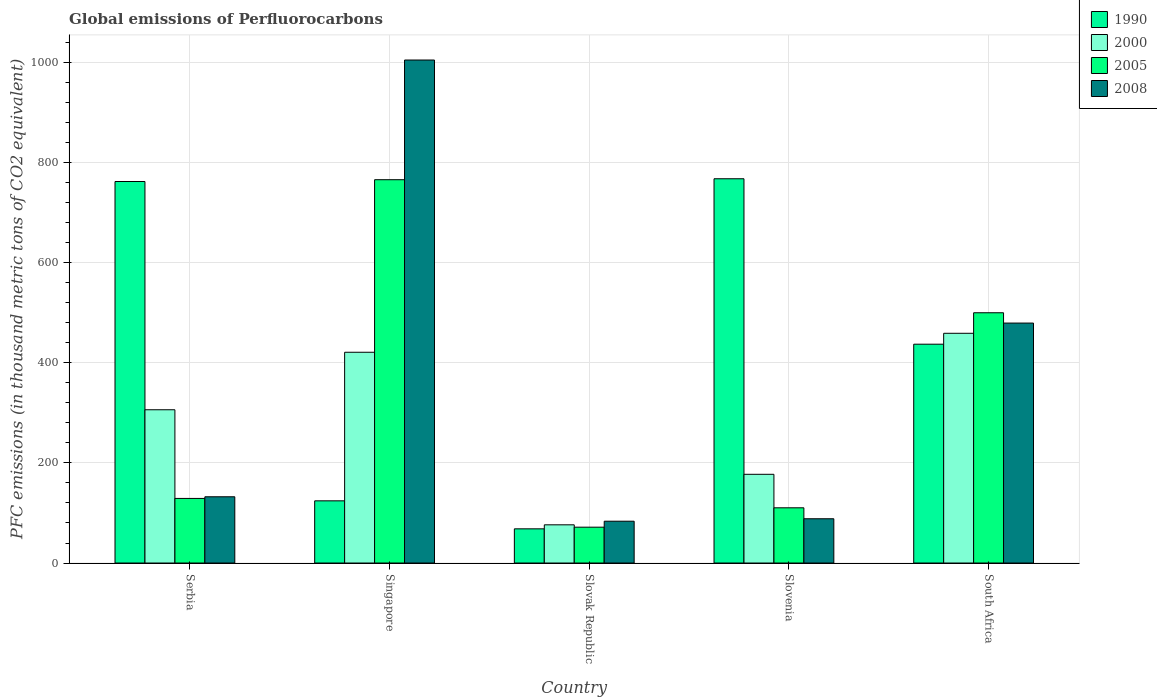How many different coloured bars are there?
Offer a terse response. 4. How many groups of bars are there?
Your answer should be very brief. 5. Are the number of bars per tick equal to the number of legend labels?
Offer a very short reply. Yes. How many bars are there on the 3rd tick from the left?
Your response must be concise. 4. How many bars are there on the 2nd tick from the right?
Offer a terse response. 4. What is the label of the 3rd group of bars from the left?
Give a very brief answer. Slovak Republic. What is the global emissions of Perfluorocarbons in 2005 in Singapore?
Provide a short and direct response. 765.5. Across all countries, what is the maximum global emissions of Perfluorocarbons in 1990?
Keep it short and to the point. 767.4. Across all countries, what is the minimum global emissions of Perfluorocarbons in 2000?
Your response must be concise. 76.3. In which country was the global emissions of Perfluorocarbons in 2005 maximum?
Your answer should be compact. Singapore. In which country was the global emissions of Perfluorocarbons in 2005 minimum?
Ensure brevity in your answer.  Slovak Republic. What is the total global emissions of Perfluorocarbons in 1990 in the graph?
Give a very brief answer. 2158.8. What is the difference between the global emissions of Perfluorocarbons in 2000 in Singapore and that in Slovak Republic?
Ensure brevity in your answer.  344.6. What is the difference between the global emissions of Perfluorocarbons in 1990 in Singapore and the global emissions of Perfluorocarbons in 2000 in Slovenia?
Offer a terse response. -53. What is the average global emissions of Perfluorocarbons in 1990 per country?
Give a very brief answer. 431.76. What is the difference between the global emissions of Perfluorocarbons of/in 1990 and global emissions of Perfluorocarbons of/in 2008 in Slovenia?
Offer a terse response. 679. In how many countries, is the global emissions of Perfluorocarbons in 2005 greater than 1000 thousand metric tons?
Your answer should be very brief. 0. What is the ratio of the global emissions of Perfluorocarbons in 2000 in Serbia to that in Singapore?
Your answer should be very brief. 0.73. Is the global emissions of Perfluorocarbons in 2005 in Slovenia less than that in South Africa?
Ensure brevity in your answer.  Yes. What is the difference between the highest and the second highest global emissions of Perfluorocarbons in 2008?
Keep it short and to the point. -872.2. What is the difference between the highest and the lowest global emissions of Perfluorocarbons in 1990?
Offer a very short reply. 699.1. How many bars are there?
Keep it short and to the point. 20. Are the values on the major ticks of Y-axis written in scientific E-notation?
Your answer should be compact. No. Does the graph contain grids?
Ensure brevity in your answer.  Yes. How many legend labels are there?
Provide a succinct answer. 4. What is the title of the graph?
Ensure brevity in your answer.  Global emissions of Perfluorocarbons. What is the label or title of the Y-axis?
Offer a very short reply. PFC emissions (in thousand metric tons of CO2 equivalent). What is the PFC emissions (in thousand metric tons of CO2 equivalent) of 1990 in Serbia?
Give a very brief answer. 761.9. What is the PFC emissions (in thousand metric tons of CO2 equivalent) in 2000 in Serbia?
Your response must be concise. 306.1. What is the PFC emissions (in thousand metric tons of CO2 equivalent) in 2005 in Serbia?
Provide a succinct answer. 129. What is the PFC emissions (in thousand metric tons of CO2 equivalent) of 2008 in Serbia?
Offer a very short reply. 132.3. What is the PFC emissions (in thousand metric tons of CO2 equivalent) of 1990 in Singapore?
Provide a short and direct response. 124.2. What is the PFC emissions (in thousand metric tons of CO2 equivalent) of 2000 in Singapore?
Provide a succinct answer. 420.9. What is the PFC emissions (in thousand metric tons of CO2 equivalent) of 2005 in Singapore?
Keep it short and to the point. 765.5. What is the PFC emissions (in thousand metric tons of CO2 equivalent) in 2008 in Singapore?
Make the answer very short. 1004.5. What is the PFC emissions (in thousand metric tons of CO2 equivalent) in 1990 in Slovak Republic?
Offer a very short reply. 68.3. What is the PFC emissions (in thousand metric tons of CO2 equivalent) of 2000 in Slovak Republic?
Your response must be concise. 76.3. What is the PFC emissions (in thousand metric tons of CO2 equivalent) in 2005 in Slovak Republic?
Your answer should be compact. 71.6. What is the PFC emissions (in thousand metric tons of CO2 equivalent) in 2008 in Slovak Republic?
Provide a short and direct response. 83.5. What is the PFC emissions (in thousand metric tons of CO2 equivalent) of 1990 in Slovenia?
Provide a short and direct response. 767.4. What is the PFC emissions (in thousand metric tons of CO2 equivalent) in 2000 in Slovenia?
Offer a terse response. 177.2. What is the PFC emissions (in thousand metric tons of CO2 equivalent) of 2005 in Slovenia?
Offer a terse response. 110.3. What is the PFC emissions (in thousand metric tons of CO2 equivalent) of 2008 in Slovenia?
Your answer should be compact. 88.4. What is the PFC emissions (in thousand metric tons of CO2 equivalent) of 1990 in South Africa?
Make the answer very short. 437. What is the PFC emissions (in thousand metric tons of CO2 equivalent) in 2000 in South Africa?
Your answer should be very brief. 458.8. What is the PFC emissions (in thousand metric tons of CO2 equivalent) of 2005 in South Africa?
Keep it short and to the point. 499.8. What is the PFC emissions (in thousand metric tons of CO2 equivalent) in 2008 in South Africa?
Your response must be concise. 479.2. Across all countries, what is the maximum PFC emissions (in thousand metric tons of CO2 equivalent) of 1990?
Your answer should be very brief. 767.4. Across all countries, what is the maximum PFC emissions (in thousand metric tons of CO2 equivalent) in 2000?
Your answer should be compact. 458.8. Across all countries, what is the maximum PFC emissions (in thousand metric tons of CO2 equivalent) of 2005?
Offer a very short reply. 765.5. Across all countries, what is the maximum PFC emissions (in thousand metric tons of CO2 equivalent) of 2008?
Give a very brief answer. 1004.5. Across all countries, what is the minimum PFC emissions (in thousand metric tons of CO2 equivalent) of 1990?
Provide a short and direct response. 68.3. Across all countries, what is the minimum PFC emissions (in thousand metric tons of CO2 equivalent) in 2000?
Provide a short and direct response. 76.3. Across all countries, what is the minimum PFC emissions (in thousand metric tons of CO2 equivalent) of 2005?
Provide a short and direct response. 71.6. Across all countries, what is the minimum PFC emissions (in thousand metric tons of CO2 equivalent) in 2008?
Provide a succinct answer. 83.5. What is the total PFC emissions (in thousand metric tons of CO2 equivalent) in 1990 in the graph?
Give a very brief answer. 2158.8. What is the total PFC emissions (in thousand metric tons of CO2 equivalent) of 2000 in the graph?
Give a very brief answer. 1439.3. What is the total PFC emissions (in thousand metric tons of CO2 equivalent) in 2005 in the graph?
Provide a short and direct response. 1576.2. What is the total PFC emissions (in thousand metric tons of CO2 equivalent) in 2008 in the graph?
Ensure brevity in your answer.  1787.9. What is the difference between the PFC emissions (in thousand metric tons of CO2 equivalent) of 1990 in Serbia and that in Singapore?
Your response must be concise. 637.7. What is the difference between the PFC emissions (in thousand metric tons of CO2 equivalent) in 2000 in Serbia and that in Singapore?
Provide a succinct answer. -114.8. What is the difference between the PFC emissions (in thousand metric tons of CO2 equivalent) in 2005 in Serbia and that in Singapore?
Keep it short and to the point. -636.5. What is the difference between the PFC emissions (in thousand metric tons of CO2 equivalent) in 2008 in Serbia and that in Singapore?
Ensure brevity in your answer.  -872.2. What is the difference between the PFC emissions (in thousand metric tons of CO2 equivalent) in 1990 in Serbia and that in Slovak Republic?
Give a very brief answer. 693.6. What is the difference between the PFC emissions (in thousand metric tons of CO2 equivalent) of 2000 in Serbia and that in Slovak Republic?
Ensure brevity in your answer.  229.8. What is the difference between the PFC emissions (in thousand metric tons of CO2 equivalent) in 2005 in Serbia and that in Slovak Republic?
Your answer should be compact. 57.4. What is the difference between the PFC emissions (in thousand metric tons of CO2 equivalent) in 2008 in Serbia and that in Slovak Republic?
Provide a succinct answer. 48.8. What is the difference between the PFC emissions (in thousand metric tons of CO2 equivalent) in 2000 in Serbia and that in Slovenia?
Keep it short and to the point. 128.9. What is the difference between the PFC emissions (in thousand metric tons of CO2 equivalent) in 2008 in Serbia and that in Slovenia?
Provide a short and direct response. 43.9. What is the difference between the PFC emissions (in thousand metric tons of CO2 equivalent) in 1990 in Serbia and that in South Africa?
Offer a terse response. 324.9. What is the difference between the PFC emissions (in thousand metric tons of CO2 equivalent) in 2000 in Serbia and that in South Africa?
Give a very brief answer. -152.7. What is the difference between the PFC emissions (in thousand metric tons of CO2 equivalent) in 2005 in Serbia and that in South Africa?
Provide a succinct answer. -370.8. What is the difference between the PFC emissions (in thousand metric tons of CO2 equivalent) in 2008 in Serbia and that in South Africa?
Your answer should be compact. -346.9. What is the difference between the PFC emissions (in thousand metric tons of CO2 equivalent) in 1990 in Singapore and that in Slovak Republic?
Make the answer very short. 55.9. What is the difference between the PFC emissions (in thousand metric tons of CO2 equivalent) of 2000 in Singapore and that in Slovak Republic?
Offer a very short reply. 344.6. What is the difference between the PFC emissions (in thousand metric tons of CO2 equivalent) in 2005 in Singapore and that in Slovak Republic?
Your answer should be compact. 693.9. What is the difference between the PFC emissions (in thousand metric tons of CO2 equivalent) of 2008 in Singapore and that in Slovak Republic?
Your answer should be compact. 921. What is the difference between the PFC emissions (in thousand metric tons of CO2 equivalent) in 1990 in Singapore and that in Slovenia?
Ensure brevity in your answer.  -643.2. What is the difference between the PFC emissions (in thousand metric tons of CO2 equivalent) of 2000 in Singapore and that in Slovenia?
Offer a very short reply. 243.7. What is the difference between the PFC emissions (in thousand metric tons of CO2 equivalent) in 2005 in Singapore and that in Slovenia?
Provide a succinct answer. 655.2. What is the difference between the PFC emissions (in thousand metric tons of CO2 equivalent) in 2008 in Singapore and that in Slovenia?
Give a very brief answer. 916.1. What is the difference between the PFC emissions (in thousand metric tons of CO2 equivalent) of 1990 in Singapore and that in South Africa?
Offer a terse response. -312.8. What is the difference between the PFC emissions (in thousand metric tons of CO2 equivalent) of 2000 in Singapore and that in South Africa?
Your answer should be compact. -37.9. What is the difference between the PFC emissions (in thousand metric tons of CO2 equivalent) in 2005 in Singapore and that in South Africa?
Your answer should be compact. 265.7. What is the difference between the PFC emissions (in thousand metric tons of CO2 equivalent) in 2008 in Singapore and that in South Africa?
Give a very brief answer. 525.3. What is the difference between the PFC emissions (in thousand metric tons of CO2 equivalent) of 1990 in Slovak Republic and that in Slovenia?
Give a very brief answer. -699.1. What is the difference between the PFC emissions (in thousand metric tons of CO2 equivalent) in 2000 in Slovak Republic and that in Slovenia?
Provide a succinct answer. -100.9. What is the difference between the PFC emissions (in thousand metric tons of CO2 equivalent) of 2005 in Slovak Republic and that in Slovenia?
Keep it short and to the point. -38.7. What is the difference between the PFC emissions (in thousand metric tons of CO2 equivalent) of 1990 in Slovak Republic and that in South Africa?
Make the answer very short. -368.7. What is the difference between the PFC emissions (in thousand metric tons of CO2 equivalent) of 2000 in Slovak Republic and that in South Africa?
Provide a short and direct response. -382.5. What is the difference between the PFC emissions (in thousand metric tons of CO2 equivalent) of 2005 in Slovak Republic and that in South Africa?
Your answer should be very brief. -428.2. What is the difference between the PFC emissions (in thousand metric tons of CO2 equivalent) of 2008 in Slovak Republic and that in South Africa?
Your answer should be compact. -395.7. What is the difference between the PFC emissions (in thousand metric tons of CO2 equivalent) in 1990 in Slovenia and that in South Africa?
Give a very brief answer. 330.4. What is the difference between the PFC emissions (in thousand metric tons of CO2 equivalent) in 2000 in Slovenia and that in South Africa?
Provide a succinct answer. -281.6. What is the difference between the PFC emissions (in thousand metric tons of CO2 equivalent) of 2005 in Slovenia and that in South Africa?
Offer a very short reply. -389.5. What is the difference between the PFC emissions (in thousand metric tons of CO2 equivalent) of 2008 in Slovenia and that in South Africa?
Offer a very short reply. -390.8. What is the difference between the PFC emissions (in thousand metric tons of CO2 equivalent) of 1990 in Serbia and the PFC emissions (in thousand metric tons of CO2 equivalent) of 2000 in Singapore?
Offer a terse response. 341. What is the difference between the PFC emissions (in thousand metric tons of CO2 equivalent) of 1990 in Serbia and the PFC emissions (in thousand metric tons of CO2 equivalent) of 2005 in Singapore?
Offer a terse response. -3.6. What is the difference between the PFC emissions (in thousand metric tons of CO2 equivalent) of 1990 in Serbia and the PFC emissions (in thousand metric tons of CO2 equivalent) of 2008 in Singapore?
Offer a terse response. -242.6. What is the difference between the PFC emissions (in thousand metric tons of CO2 equivalent) of 2000 in Serbia and the PFC emissions (in thousand metric tons of CO2 equivalent) of 2005 in Singapore?
Ensure brevity in your answer.  -459.4. What is the difference between the PFC emissions (in thousand metric tons of CO2 equivalent) in 2000 in Serbia and the PFC emissions (in thousand metric tons of CO2 equivalent) in 2008 in Singapore?
Make the answer very short. -698.4. What is the difference between the PFC emissions (in thousand metric tons of CO2 equivalent) of 2005 in Serbia and the PFC emissions (in thousand metric tons of CO2 equivalent) of 2008 in Singapore?
Offer a terse response. -875.5. What is the difference between the PFC emissions (in thousand metric tons of CO2 equivalent) of 1990 in Serbia and the PFC emissions (in thousand metric tons of CO2 equivalent) of 2000 in Slovak Republic?
Give a very brief answer. 685.6. What is the difference between the PFC emissions (in thousand metric tons of CO2 equivalent) of 1990 in Serbia and the PFC emissions (in thousand metric tons of CO2 equivalent) of 2005 in Slovak Republic?
Ensure brevity in your answer.  690.3. What is the difference between the PFC emissions (in thousand metric tons of CO2 equivalent) of 1990 in Serbia and the PFC emissions (in thousand metric tons of CO2 equivalent) of 2008 in Slovak Republic?
Ensure brevity in your answer.  678.4. What is the difference between the PFC emissions (in thousand metric tons of CO2 equivalent) of 2000 in Serbia and the PFC emissions (in thousand metric tons of CO2 equivalent) of 2005 in Slovak Republic?
Provide a short and direct response. 234.5. What is the difference between the PFC emissions (in thousand metric tons of CO2 equivalent) of 2000 in Serbia and the PFC emissions (in thousand metric tons of CO2 equivalent) of 2008 in Slovak Republic?
Offer a very short reply. 222.6. What is the difference between the PFC emissions (in thousand metric tons of CO2 equivalent) in 2005 in Serbia and the PFC emissions (in thousand metric tons of CO2 equivalent) in 2008 in Slovak Republic?
Ensure brevity in your answer.  45.5. What is the difference between the PFC emissions (in thousand metric tons of CO2 equivalent) in 1990 in Serbia and the PFC emissions (in thousand metric tons of CO2 equivalent) in 2000 in Slovenia?
Offer a very short reply. 584.7. What is the difference between the PFC emissions (in thousand metric tons of CO2 equivalent) in 1990 in Serbia and the PFC emissions (in thousand metric tons of CO2 equivalent) in 2005 in Slovenia?
Your response must be concise. 651.6. What is the difference between the PFC emissions (in thousand metric tons of CO2 equivalent) of 1990 in Serbia and the PFC emissions (in thousand metric tons of CO2 equivalent) of 2008 in Slovenia?
Give a very brief answer. 673.5. What is the difference between the PFC emissions (in thousand metric tons of CO2 equivalent) in 2000 in Serbia and the PFC emissions (in thousand metric tons of CO2 equivalent) in 2005 in Slovenia?
Provide a succinct answer. 195.8. What is the difference between the PFC emissions (in thousand metric tons of CO2 equivalent) of 2000 in Serbia and the PFC emissions (in thousand metric tons of CO2 equivalent) of 2008 in Slovenia?
Your response must be concise. 217.7. What is the difference between the PFC emissions (in thousand metric tons of CO2 equivalent) in 2005 in Serbia and the PFC emissions (in thousand metric tons of CO2 equivalent) in 2008 in Slovenia?
Provide a succinct answer. 40.6. What is the difference between the PFC emissions (in thousand metric tons of CO2 equivalent) in 1990 in Serbia and the PFC emissions (in thousand metric tons of CO2 equivalent) in 2000 in South Africa?
Offer a terse response. 303.1. What is the difference between the PFC emissions (in thousand metric tons of CO2 equivalent) of 1990 in Serbia and the PFC emissions (in thousand metric tons of CO2 equivalent) of 2005 in South Africa?
Your answer should be very brief. 262.1. What is the difference between the PFC emissions (in thousand metric tons of CO2 equivalent) in 1990 in Serbia and the PFC emissions (in thousand metric tons of CO2 equivalent) in 2008 in South Africa?
Keep it short and to the point. 282.7. What is the difference between the PFC emissions (in thousand metric tons of CO2 equivalent) of 2000 in Serbia and the PFC emissions (in thousand metric tons of CO2 equivalent) of 2005 in South Africa?
Keep it short and to the point. -193.7. What is the difference between the PFC emissions (in thousand metric tons of CO2 equivalent) in 2000 in Serbia and the PFC emissions (in thousand metric tons of CO2 equivalent) in 2008 in South Africa?
Offer a very short reply. -173.1. What is the difference between the PFC emissions (in thousand metric tons of CO2 equivalent) in 2005 in Serbia and the PFC emissions (in thousand metric tons of CO2 equivalent) in 2008 in South Africa?
Offer a terse response. -350.2. What is the difference between the PFC emissions (in thousand metric tons of CO2 equivalent) of 1990 in Singapore and the PFC emissions (in thousand metric tons of CO2 equivalent) of 2000 in Slovak Republic?
Your answer should be compact. 47.9. What is the difference between the PFC emissions (in thousand metric tons of CO2 equivalent) of 1990 in Singapore and the PFC emissions (in thousand metric tons of CO2 equivalent) of 2005 in Slovak Republic?
Your response must be concise. 52.6. What is the difference between the PFC emissions (in thousand metric tons of CO2 equivalent) in 1990 in Singapore and the PFC emissions (in thousand metric tons of CO2 equivalent) in 2008 in Slovak Republic?
Ensure brevity in your answer.  40.7. What is the difference between the PFC emissions (in thousand metric tons of CO2 equivalent) in 2000 in Singapore and the PFC emissions (in thousand metric tons of CO2 equivalent) in 2005 in Slovak Republic?
Offer a terse response. 349.3. What is the difference between the PFC emissions (in thousand metric tons of CO2 equivalent) of 2000 in Singapore and the PFC emissions (in thousand metric tons of CO2 equivalent) of 2008 in Slovak Republic?
Your response must be concise. 337.4. What is the difference between the PFC emissions (in thousand metric tons of CO2 equivalent) of 2005 in Singapore and the PFC emissions (in thousand metric tons of CO2 equivalent) of 2008 in Slovak Republic?
Your answer should be very brief. 682. What is the difference between the PFC emissions (in thousand metric tons of CO2 equivalent) in 1990 in Singapore and the PFC emissions (in thousand metric tons of CO2 equivalent) in 2000 in Slovenia?
Your response must be concise. -53. What is the difference between the PFC emissions (in thousand metric tons of CO2 equivalent) of 1990 in Singapore and the PFC emissions (in thousand metric tons of CO2 equivalent) of 2008 in Slovenia?
Your answer should be very brief. 35.8. What is the difference between the PFC emissions (in thousand metric tons of CO2 equivalent) of 2000 in Singapore and the PFC emissions (in thousand metric tons of CO2 equivalent) of 2005 in Slovenia?
Your response must be concise. 310.6. What is the difference between the PFC emissions (in thousand metric tons of CO2 equivalent) of 2000 in Singapore and the PFC emissions (in thousand metric tons of CO2 equivalent) of 2008 in Slovenia?
Give a very brief answer. 332.5. What is the difference between the PFC emissions (in thousand metric tons of CO2 equivalent) in 2005 in Singapore and the PFC emissions (in thousand metric tons of CO2 equivalent) in 2008 in Slovenia?
Make the answer very short. 677.1. What is the difference between the PFC emissions (in thousand metric tons of CO2 equivalent) in 1990 in Singapore and the PFC emissions (in thousand metric tons of CO2 equivalent) in 2000 in South Africa?
Provide a short and direct response. -334.6. What is the difference between the PFC emissions (in thousand metric tons of CO2 equivalent) in 1990 in Singapore and the PFC emissions (in thousand metric tons of CO2 equivalent) in 2005 in South Africa?
Give a very brief answer. -375.6. What is the difference between the PFC emissions (in thousand metric tons of CO2 equivalent) of 1990 in Singapore and the PFC emissions (in thousand metric tons of CO2 equivalent) of 2008 in South Africa?
Give a very brief answer. -355. What is the difference between the PFC emissions (in thousand metric tons of CO2 equivalent) in 2000 in Singapore and the PFC emissions (in thousand metric tons of CO2 equivalent) in 2005 in South Africa?
Provide a short and direct response. -78.9. What is the difference between the PFC emissions (in thousand metric tons of CO2 equivalent) in 2000 in Singapore and the PFC emissions (in thousand metric tons of CO2 equivalent) in 2008 in South Africa?
Keep it short and to the point. -58.3. What is the difference between the PFC emissions (in thousand metric tons of CO2 equivalent) in 2005 in Singapore and the PFC emissions (in thousand metric tons of CO2 equivalent) in 2008 in South Africa?
Offer a terse response. 286.3. What is the difference between the PFC emissions (in thousand metric tons of CO2 equivalent) of 1990 in Slovak Republic and the PFC emissions (in thousand metric tons of CO2 equivalent) of 2000 in Slovenia?
Your answer should be compact. -108.9. What is the difference between the PFC emissions (in thousand metric tons of CO2 equivalent) of 1990 in Slovak Republic and the PFC emissions (in thousand metric tons of CO2 equivalent) of 2005 in Slovenia?
Offer a terse response. -42. What is the difference between the PFC emissions (in thousand metric tons of CO2 equivalent) of 1990 in Slovak Republic and the PFC emissions (in thousand metric tons of CO2 equivalent) of 2008 in Slovenia?
Your answer should be very brief. -20.1. What is the difference between the PFC emissions (in thousand metric tons of CO2 equivalent) of 2000 in Slovak Republic and the PFC emissions (in thousand metric tons of CO2 equivalent) of 2005 in Slovenia?
Give a very brief answer. -34. What is the difference between the PFC emissions (in thousand metric tons of CO2 equivalent) in 2000 in Slovak Republic and the PFC emissions (in thousand metric tons of CO2 equivalent) in 2008 in Slovenia?
Your answer should be very brief. -12.1. What is the difference between the PFC emissions (in thousand metric tons of CO2 equivalent) in 2005 in Slovak Republic and the PFC emissions (in thousand metric tons of CO2 equivalent) in 2008 in Slovenia?
Provide a short and direct response. -16.8. What is the difference between the PFC emissions (in thousand metric tons of CO2 equivalent) of 1990 in Slovak Republic and the PFC emissions (in thousand metric tons of CO2 equivalent) of 2000 in South Africa?
Make the answer very short. -390.5. What is the difference between the PFC emissions (in thousand metric tons of CO2 equivalent) of 1990 in Slovak Republic and the PFC emissions (in thousand metric tons of CO2 equivalent) of 2005 in South Africa?
Your response must be concise. -431.5. What is the difference between the PFC emissions (in thousand metric tons of CO2 equivalent) of 1990 in Slovak Republic and the PFC emissions (in thousand metric tons of CO2 equivalent) of 2008 in South Africa?
Your answer should be compact. -410.9. What is the difference between the PFC emissions (in thousand metric tons of CO2 equivalent) in 2000 in Slovak Republic and the PFC emissions (in thousand metric tons of CO2 equivalent) in 2005 in South Africa?
Give a very brief answer. -423.5. What is the difference between the PFC emissions (in thousand metric tons of CO2 equivalent) in 2000 in Slovak Republic and the PFC emissions (in thousand metric tons of CO2 equivalent) in 2008 in South Africa?
Provide a succinct answer. -402.9. What is the difference between the PFC emissions (in thousand metric tons of CO2 equivalent) of 2005 in Slovak Republic and the PFC emissions (in thousand metric tons of CO2 equivalent) of 2008 in South Africa?
Your answer should be very brief. -407.6. What is the difference between the PFC emissions (in thousand metric tons of CO2 equivalent) of 1990 in Slovenia and the PFC emissions (in thousand metric tons of CO2 equivalent) of 2000 in South Africa?
Make the answer very short. 308.6. What is the difference between the PFC emissions (in thousand metric tons of CO2 equivalent) of 1990 in Slovenia and the PFC emissions (in thousand metric tons of CO2 equivalent) of 2005 in South Africa?
Your response must be concise. 267.6. What is the difference between the PFC emissions (in thousand metric tons of CO2 equivalent) in 1990 in Slovenia and the PFC emissions (in thousand metric tons of CO2 equivalent) in 2008 in South Africa?
Keep it short and to the point. 288.2. What is the difference between the PFC emissions (in thousand metric tons of CO2 equivalent) of 2000 in Slovenia and the PFC emissions (in thousand metric tons of CO2 equivalent) of 2005 in South Africa?
Your answer should be compact. -322.6. What is the difference between the PFC emissions (in thousand metric tons of CO2 equivalent) of 2000 in Slovenia and the PFC emissions (in thousand metric tons of CO2 equivalent) of 2008 in South Africa?
Your response must be concise. -302. What is the difference between the PFC emissions (in thousand metric tons of CO2 equivalent) in 2005 in Slovenia and the PFC emissions (in thousand metric tons of CO2 equivalent) in 2008 in South Africa?
Provide a succinct answer. -368.9. What is the average PFC emissions (in thousand metric tons of CO2 equivalent) of 1990 per country?
Provide a succinct answer. 431.76. What is the average PFC emissions (in thousand metric tons of CO2 equivalent) of 2000 per country?
Your answer should be compact. 287.86. What is the average PFC emissions (in thousand metric tons of CO2 equivalent) of 2005 per country?
Your response must be concise. 315.24. What is the average PFC emissions (in thousand metric tons of CO2 equivalent) of 2008 per country?
Make the answer very short. 357.58. What is the difference between the PFC emissions (in thousand metric tons of CO2 equivalent) of 1990 and PFC emissions (in thousand metric tons of CO2 equivalent) of 2000 in Serbia?
Give a very brief answer. 455.8. What is the difference between the PFC emissions (in thousand metric tons of CO2 equivalent) of 1990 and PFC emissions (in thousand metric tons of CO2 equivalent) of 2005 in Serbia?
Your answer should be very brief. 632.9. What is the difference between the PFC emissions (in thousand metric tons of CO2 equivalent) of 1990 and PFC emissions (in thousand metric tons of CO2 equivalent) of 2008 in Serbia?
Provide a short and direct response. 629.6. What is the difference between the PFC emissions (in thousand metric tons of CO2 equivalent) in 2000 and PFC emissions (in thousand metric tons of CO2 equivalent) in 2005 in Serbia?
Your response must be concise. 177.1. What is the difference between the PFC emissions (in thousand metric tons of CO2 equivalent) in 2000 and PFC emissions (in thousand metric tons of CO2 equivalent) in 2008 in Serbia?
Your answer should be compact. 173.8. What is the difference between the PFC emissions (in thousand metric tons of CO2 equivalent) of 2005 and PFC emissions (in thousand metric tons of CO2 equivalent) of 2008 in Serbia?
Make the answer very short. -3.3. What is the difference between the PFC emissions (in thousand metric tons of CO2 equivalent) in 1990 and PFC emissions (in thousand metric tons of CO2 equivalent) in 2000 in Singapore?
Your response must be concise. -296.7. What is the difference between the PFC emissions (in thousand metric tons of CO2 equivalent) in 1990 and PFC emissions (in thousand metric tons of CO2 equivalent) in 2005 in Singapore?
Offer a very short reply. -641.3. What is the difference between the PFC emissions (in thousand metric tons of CO2 equivalent) of 1990 and PFC emissions (in thousand metric tons of CO2 equivalent) of 2008 in Singapore?
Offer a very short reply. -880.3. What is the difference between the PFC emissions (in thousand metric tons of CO2 equivalent) of 2000 and PFC emissions (in thousand metric tons of CO2 equivalent) of 2005 in Singapore?
Make the answer very short. -344.6. What is the difference between the PFC emissions (in thousand metric tons of CO2 equivalent) in 2000 and PFC emissions (in thousand metric tons of CO2 equivalent) in 2008 in Singapore?
Give a very brief answer. -583.6. What is the difference between the PFC emissions (in thousand metric tons of CO2 equivalent) of 2005 and PFC emissions (in thousand metric tons of CO2 equivalent) of 2008 in Singapore?
Your answer should be compact. -239. What is the difference between the PFC emissions (in thousand metric tons of CO2 equivalent) of 1990 and PFC emissions (in thousand metric tons of CO2 equivalent) of 2008 in Slovak Republic?
Ensure brevity in your answer.  -15.2. What is the difference between the PFC emissions (in thousand metric tons of CO2 equivalent) in 2000 and PFC emissions (in thousand metric tons of CO2 equivalent) in 2008 in Slovak Republic?
Your answer should be compact. -7.2. What is the difference between the PFC emissions (in thousand metric tons of CO2 equivalent) in 1990 and PFC emissions (in thousand metric tons of CO2 equivalent) in 2000 in Slovenia?
Your answer should be compact. 590.2. What is the difference between the PFC emissions (in thousand metric tons of CO2 equivalent) in 1990 and PFC emissions (in thousand metric tons of CO2 equivalent) in 2005 in Slovenia?
Keep it short and to the point. 657.1. What is the difference between the PFC emissions (in thousand metric tons of CO2 equivalent) in 1990 and PFC emissions (in thousand metric tons of CO2 equivalent) in 2008 in Slovenia?
Make the answer very short. 679. What is the difference between the PFC emissions (in thousand metric tons of CO2 equivalent) in 2000 and PFC emissions (in thousand metric tons of CO2 equivalent) in 2005 in Slovenia?
Provide a succinct answer. 66.9. What is the difference between the PFC emissions (in thousand metric tons of CO2 equivalent) in 2000 and PFC emissions (in thousand metric tons of CO2 equivalent) in 2008 in Slovenia?
Offer a terse response. 88.8. What is the difference between the PFC emissions (in thousand metric tons of CO2 equivalent) in 2005 and PFC emissions (in thousand metric tons of CO2 equivalent) in 2008 in Slovenia?
Make the answer very short. 21.9. What is the difference between the PFC emissions (in thousand metric tons of CO2 equivalent) in 1990 and PFC emissions (in thousand metric tons of CO2 equivalent) in 2000 in South Africa?
Your answer should be compact. -21.8. What is the difference between the PFC emissions (in thousand metric tons of CO2 equivalent) of 1990 and PFC emissions (in thousand metric tons of CO2 equivalent) of 2005 in South Africa?
Give a very brief answer. -62.8. What is the difference between the PFC emissions (in thousand metric tons of CO2 equivalent) of 1990 and PFC emissions (in thousand metric tons of CO2 equivalent) of 2008 in South Africa?
Provide a succinct answer. -42.2. What is the difference between the PFC emissions (in thousand metric tons of CO2 equivalent) of 2000 and PFC emissions (in thousand metric tons of CO2 equivalent) of 2005 in South Africa?
Offer a very short reply. -41. What is the difference between the PFC emissions (in thousand metric tons of CO2 equivalent) of 2000 and PFC emissions (in thousand metric tons of CO2 equivalent) of 2008 in South Africa?
Provide a short and direct response. -20.4. What is the difference between the PFC emissions (in thousand metric tons of CO2 equivalent) of 2005 and PFC emissions (in thousand metric tons of CO2 equivalent) of 2008 in South Africa?
Offer a very short reply. 20.6. What is the ratio of the PFC emissions (in thousand metric tons of CO2 equivalent) of 1990 in Serbia to that in Singapore?
Offer a terse response. 6.13. What is the ratio of the PFC emissions (in thousand metric tons of CO2 equivalent) in 2000 in Serbia to that in Singapore?
Your answer should be compact. 0.73. What is the ratio of the PFC emissions (in thousand metric tons of CO2 equivalent) of 2005 in Serbia to that in Singapore?
Provide a succinct answer. 0.17. What is the ratio of the PFC emissions (in thousand metric tons of CO2 equivalent) in 2008 in Serbia to that in Singapore?
Offer a terse response. 0.13. What is the ratio of the PFC emissions (in thousand metric tons of CO2 equivalent) in 1990 in Serbia to that in Slovak Republic?
Provide a short and direct response. 11.16. What is the ratio of the PFC emissions (in thousand metric tons of CO2 equivalent) of 2000 in Serbia to that in Slovak Republic?
Your answer should be very brief. 4.01. What is the ratio of the PFC emissions (in thousand metric tons of CO2 equivalent) in 2005 in Serbia to that in Slovak Republic?
Keep it short and to the point. 1.8. What is the ratio of the PFC emissions (in thousand metric tons of CO2 equivalent) of 2008 in Serbia to that in Slovak Republic?
Your answer should be very brief. 1.58. What is the ratio of the PFC emissions (in thousand metric tons of CO2 equivalent) in 1990 in Serbia to that in Slovenia?
Your response must be concise. 0.99. What is the ratio of the PFC emissions (in thousand metric tons of CO2 equivalent) of 2000 in Serbia to that in Slovenia?
Give a very brief answer. 1.73. What is the ratio of the PFC emissions (in thousand metric tons of CO2 equivalent) in 2005 in Serbia to that in Slovenia?
Offer a very short reply. 1.17. What is the ratio of the PFC emissions (in thousand metric tons of CO2 equivalent) in 2008 in Serbia to that in Slovenia?
Your response must be concise. 1.5. What is the ratio of the PFC emissions (in thousand metric tons of CO2 equivalent) of 1990 in Serbia to that in South Africa?
Your answer should be compact. 1.74. What is the ratio of the PFC emissions (in thousand metric tons of CO2 equivalent) in 2000 in Serbia to that in South Africa?
Your response must be concise. 0.67. What is the ratio of the PFC emissions (in thousand metric tons of CO2 equivalent) of 2005 in Serbia to that in South Africa?
Provide a succinct answer. 0.26. What is the ratio of the PFC emissions (in thousand metric tons of CO2 equivalent) of 2008 in Serbia to that in South Africa?
Your answer should be very brief. 0.28. What is the ratio of the PFC emissions (in thousand metric tons of CO2 equivalent) of 1990 in Singapore to that in Slovak Republic?
Keep it short and to the point. 1.82. What is the ratio of the PFC emissions (in thousand metric tons of CO2 equivalent) in 2000 in Singapore to that in Slovak Republic?
Make the answer very short. 5.52. What is the ratio of the PFC emissions (in thousand metric tons of CO2 equivalent) in 2005 in Singapore to that in Slovak Republic?
Your answer should be compact. 10.69. What is the ratio of the PFC emissions (in thousand metric tons of CO2 equivalent) in 2008 in Singapore to that in Slovak Republic?
Your response must be concise. 12.03. What is the ratio of the PFC emissions (in thousand metric tons of CO2 equivalent) of 1990 in Singapore to that in Slovenia?
Provide a short and direct response. 0.16. What is the ratio of the PFC emissions (in thousand metric tons of CO2 equivalent) in 2000 in Singapore to that in Slovenia?
Offer a terse response. 2.38. What is the ratio of the PFC emissions (in thousand metric tons of CO2 equivalent) of 2005 in Singapore to that in Slovenia?
Give a very brief answer. 6.94. What is the ratio of the PFC emissions (in thousand metric tons of CO2 equivalent) in 2008 in Singapore to that in Slovenia?
Keep it short and to the point. 11.36. What is the ratio of the PFC emissions (in thousand metric tons of CO2 equivalent) of 1990 in Singapore to that in South Africa?
Your answer should be very brief. 0.28. What is the ratio of the PFC emissions (in thousand metric tons of CO2 equivalent) in 2000 in Singapore to that in South Africa?
Your answer should be compact. 0.92. What is the ratio of the PFC emissions (in thousand metric tons of CO2 equivalent) of 2005 in Singapore to that in South Africa?
Keep it short and to the point. 1.53. What is the ratio of the PFC emissions (in thousand metric tons of CO2 equivalent) in 2008 in Singapore to that in South Africa?
Make the answer very short. 2.1. What is the ratio of the PFC emissions (in thousand metric tons of CO2 equivalent) of 1990 in Slovak Republic to that in Slovenia?
Keep it short and to the point. 0.09. What is the ratio of the PFC emissions (in thousand metric tons of CO2 equivalent) in 2000 in Slovak Republic to that in Slovenia?
Offer a terse response. 0.43. What is the ratio of the PFC emissions (in thousand metric tons of CO2 equivalent) of 2005 in Slovak Republic to that in Slovenia?
Offer a terse response. 0.65. What is the ratio of the PFC emissions (in thousand metric tons of CO2 equivalent) in 2008 in Slovak Republic to that in Slovenia?
Offer a very short reply. 0.94. What is the ratio of the PFC emissions (in thousand metric tons of CO2 equivalent) in 1990 in Slovak Republic to that in South Africa?
Offer a terse response. 0.16. What is the ratio of the PFC emissions (in thousand metric tons of CO2 equivalent) in 2000 in Slovak Republic to that in South Africa?
Make the answer very short. 0.17. What is the ratio of the PFC emissions (in thousand metric tons of CO2 equivalent) in 2005 in Slovak Republic to that in South Africa?
Offer a terse response. 0.14. What is the ratio of the PFC emissions (in thousand metric tons of CO2 equivalent) in 2008 in Slovak Republic to that in South Africa?
Provide a succinct answer. 0.17. What is the ratio of the PFC emissions (in thousand metric tons of CO2 equivalent) in 1990 in Slovenia to that in South Africa?
Your response must be concise. 1.76. What is the ratio of the PFC emissions (in thousand metric tons of CO2 equivalent) of 2000 in Slovenia to that in South Africa?
Your answer should be very brief. 0.39. What is the ratio of the PFC emissions (in thousand metric tons of CO2 equivalent) of 2005 in Slovenia to that in South Africa?
Provide a short and direct response. 0.22. What is the ratio of the PFC emissions (in thousand metric tons of CO2 equivalent) of 2008 in Slovenia to that in South Africa?
Provide a succinct answer. 0.18. What is the difference between the highest and the second highest PFC emissions (in thousand metric tons of CO2 equivalent) of 1990?
Provide a succinct answer. 5.5. What is the difference between the highest and the second highest PFC emissions (in thousand metric tons of CO2 equivalent) in 2000?
Your answer should be very brief. 37.9. What is the difference between the highest and the second highest PFC emissions (in thousand metric tons of CO2 equivalent) in 2005?
Provide a succinct answer. 265.7. What is the difference between the highest and the second highest PFC emissions (in thousand metric tons of CO2 equivalent) in 2008?
Your response must be concise. 525.3. What is the difference between the highest and the lowest PFC emissions (in thousand metric tons of CO2 equivalent) in 1990?
Ensure brevity in your answer.  699.1. What is the difference between the highest and the lowest PFC emissions (in thousand metric tons of CO2 equivalent) of 2000?
Give a very brief answer. 382.5. What is the difference between the highest and the lowest PFC emissions (in thousand metric tons of CO2 equivalent) in 2005?
Ensure brevity in your answer.  693.9. What is the difference between the highest and the lowest PFC emissions (in thousand metric tons of CO2 equivalent) of 2008?
Provide a short and direct response. 921. 